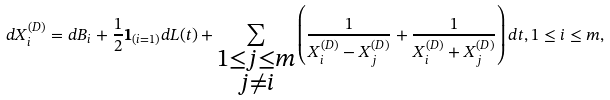Convert formula to latex. <formula><loc_0><loc_0><loc_500><loc_500>d X _ { i } ^ { ( D ) } = d B _ { i } + \frac { 1 } { 2 } { \mathbf 1 } _ { ( i = 1 ) } d L ( t ) + \sum _ { \substack { 1 \leq j \leq m \\ j \neq i } } \left ( \frac { 1 } { X _ { i } ^ { ( D ) } - X _ { j } ^ { ( D ) } } + \frac { 1 } { X _ { i } ^ { ( D ) } + X _ { j } ^ { ( D ) } } \right ) d t , 1 \leq i \leq m ,</formula> 